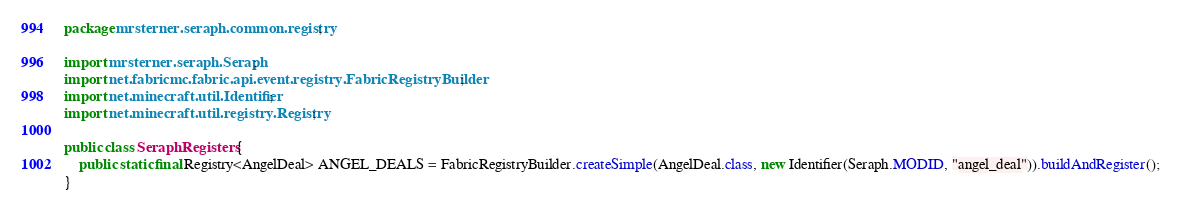Convert code to text. <code><loc_0><loc_0><loc_500><loc_500><_Java_>package mrsterner.seraph.common.registry;

import mrsterner.seraph.Seraph;
import net.fabricmc.fabric.api.event.registry.FabricRegistryBuilder;
import net.minecraft.util.Identifier;
import net.minecraft.util.registry.Registry;

public class SeraphRegisters {
    public static final Registry<AngelDeal> ANGEL_DEALS = FabricRegistryBuilder.createSimple(AngelDeal.class, new Identifier(Seraph.MODID, "angel_deal")).buildAndRegister();
}
</code> 